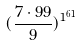Convert formula to latex. <formula><loc_0><loc_0><loc_500><loc_500>( \frac { 7 \cdot 9 9 } { 9 } ) ^ { 1 ^ { 6 1 } }</formula> 